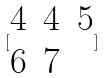<formula> <loc_0><loc_0><loc_500><loc_500>[ \begin{matrix} 4 & 4 & 5 \\ 6 & 7 \end{matrix} ]</formula> 